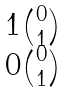<formula> <loc_0><loc_0><loc_500><loc_500>\begin{matrix} 1 \binom { 0 } { 1 } \\ 0 \binom { 0 } { 1 } \end{matrix}</formula> 